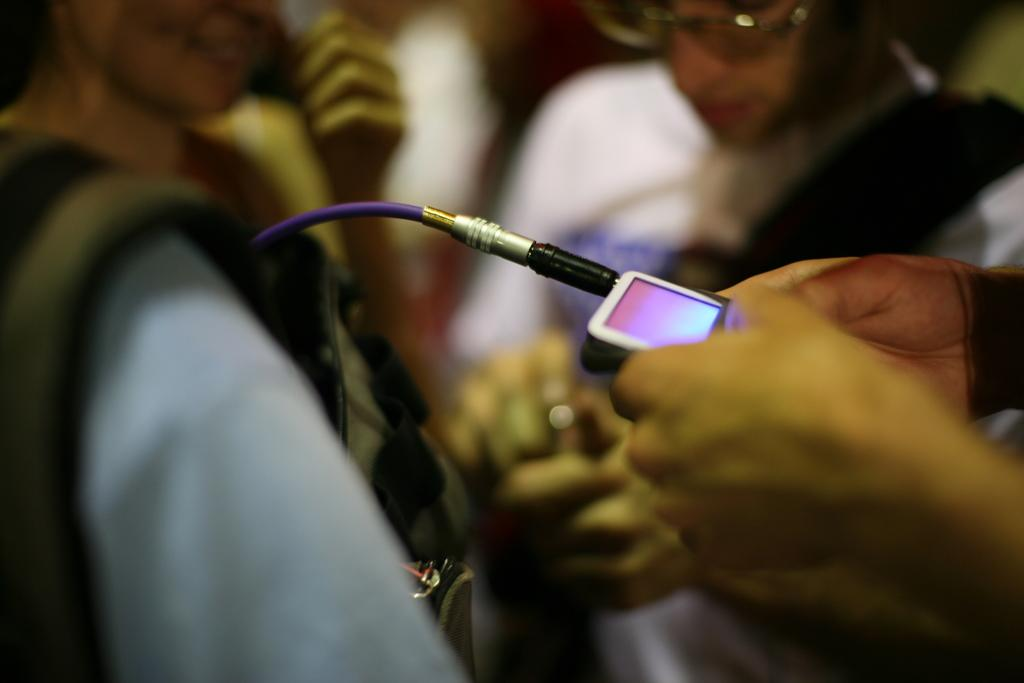What is being held by the hands in the image? There are hands holding a device in the image. What else can be seen in the image besides the hands and device? There is a cable visible in the image. How would you describe the background of the image? The background of the image is blurred. How many people are present in the image? There are two people in the image. Is the device being used to represent the sleet in the image? There is no sleet present in the image, and the device is not being used to represent anything. 